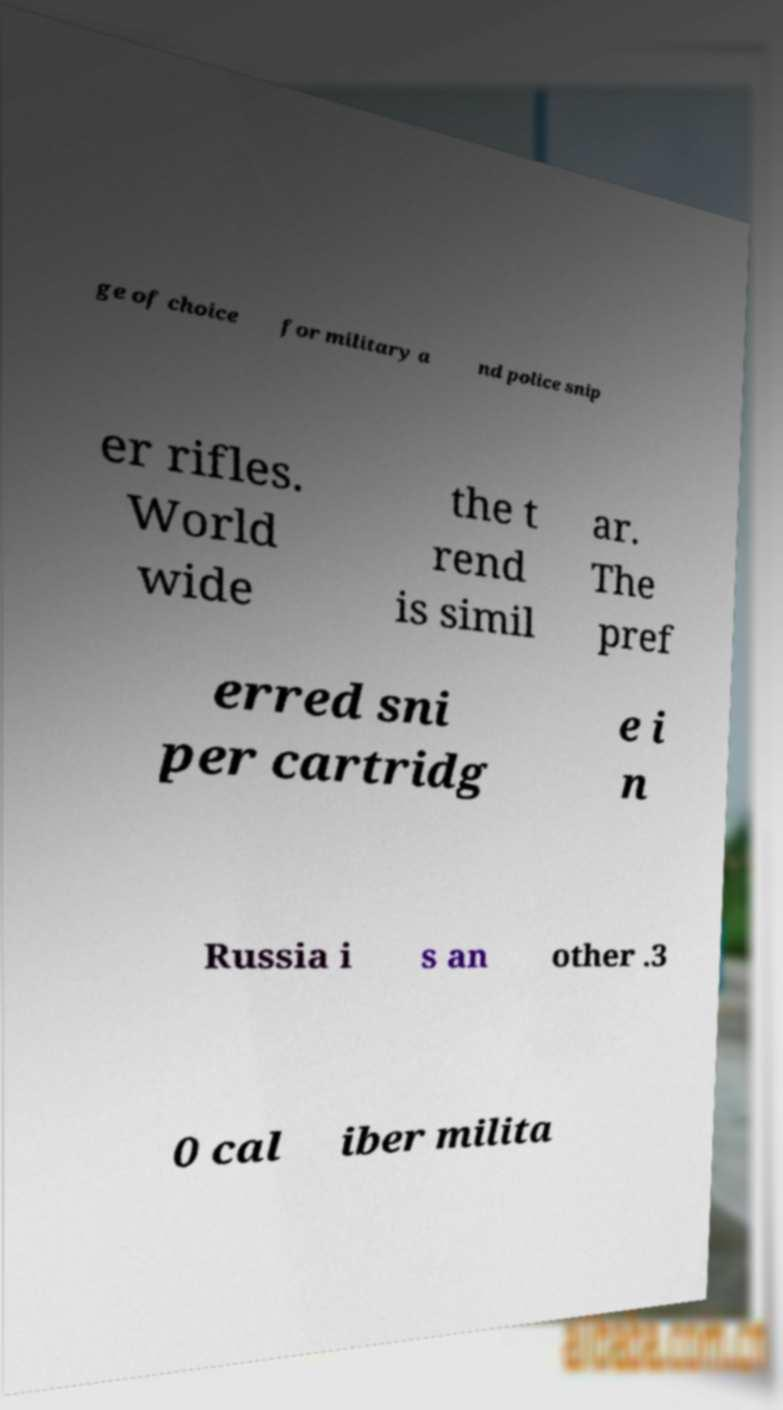I need the written content from this picture converted into text. Can you do that? ge of choice for military a nd police snip er rifles. World wide the t rend is simil ar. The pref erred sni per cartridg e i n Russia i s an other .3 0 cal iber milita 